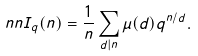Convert formula to latex. <formula><loc_0><loc_0><loc_500><loc_500>\ n n I _ { q } ( n ) = \frac { 1 } { n } \sum _ { d | n } \mu ( d ) q ^ { n / d } .</formula> 